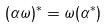Convert formula to latex. <formula><loc_0><loc_0><loc_500><loc_500>( \alpha \omega ) ^ { * } = \omega ( \alpha ^ { * } )</formula> 